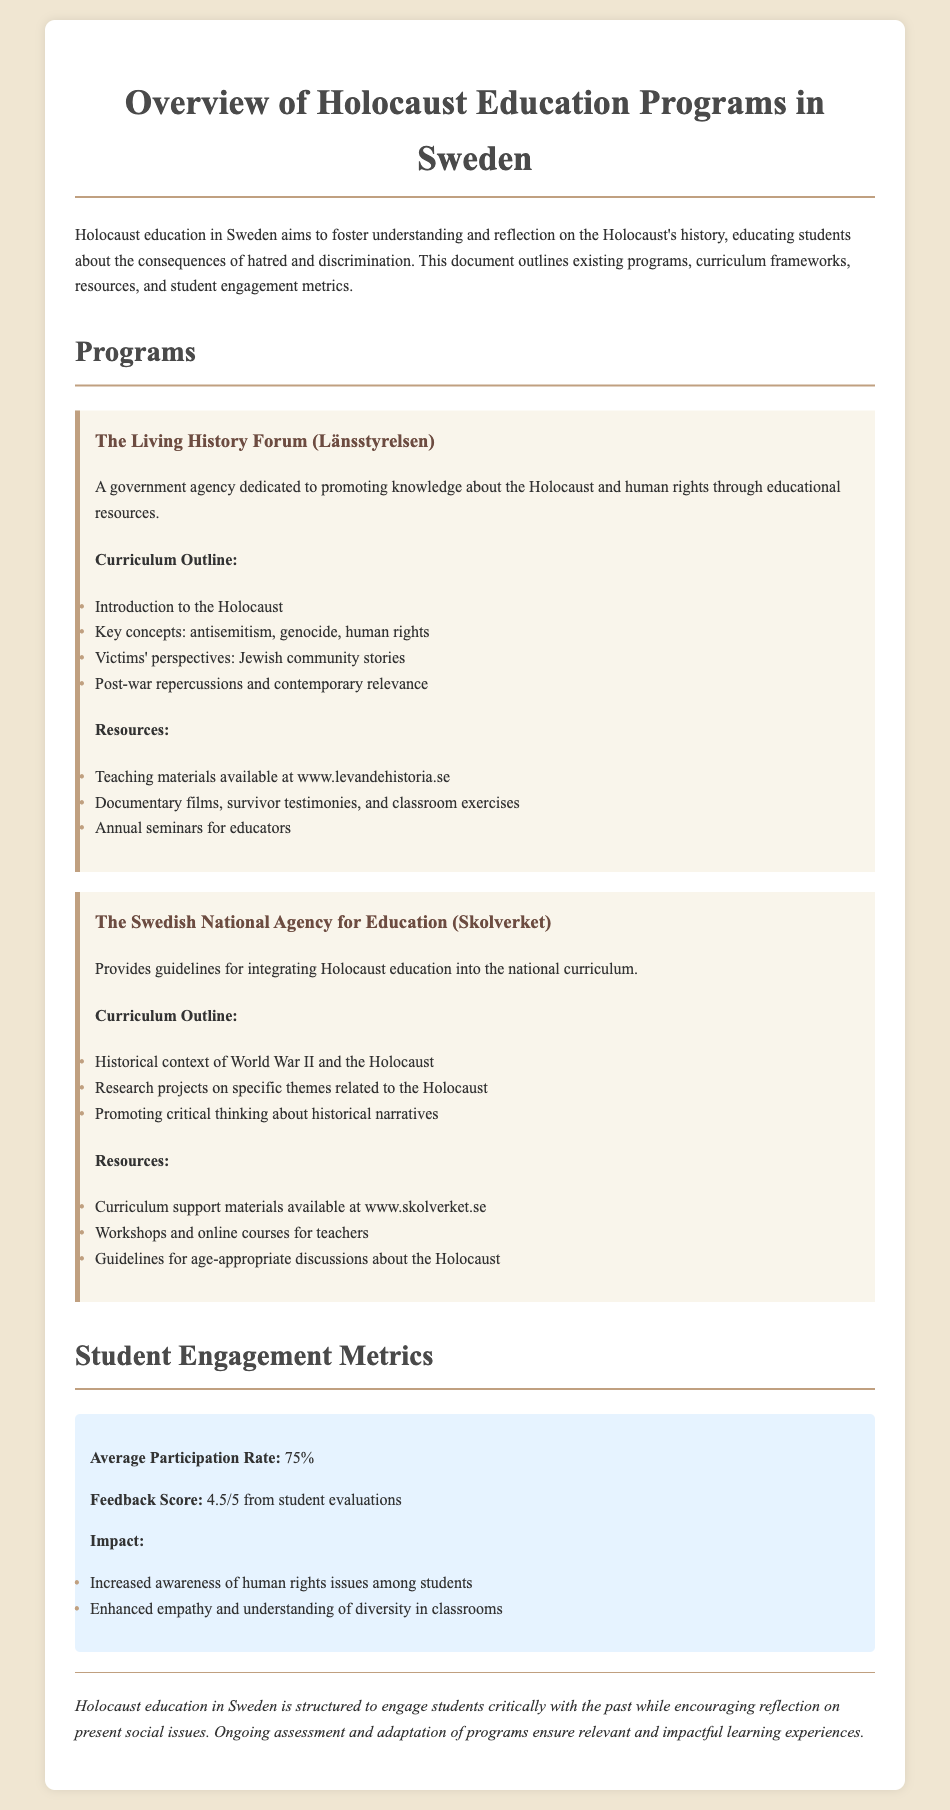What is the name of the government agency focused on Holocaust education? The document states that "The Living History Forum" is a government agency dedicated to promoting knowledge about the Holocaust.
Answer: The Living History Forum What is the curriculum outline's first topic under The Living History Forum? The document lists "Introduction to the Holocaust" as the first topic in the curriculum outline.
Answer: Introduction to the Holocaust What is the average participation rate for Holocaust education programs? The document indicates that the average participation rate is 75%.
Answer: 75% Which institution provides guidelines for integrating Holocaust education into the national curriculum? The document mentions "The Swedish National Agency for Education" as the provider of guidelines.
Answer: The Swedish National Agency for Education What is the feedback score from student evaluations? The document states that the feedback score is 4.5 out of 5 from evaluations.
Answer: 4.5/5 What type of resources does The Swedish National Agency for Education provide? The document states that it provides "curriculum support materials available at www.skolverket.se".
Answer: Curriculum support materials What is the main goal of Holocaust education in Sweden? The document describes the aim as fostering understanding and reflection on the Holocaust's history.
Answer: Understanding and reflection What percentage of students reported increased awareness of human rights issues? The document highlights an increase in awareness, though it does not provide a specific percentage; this represents an aspect of engagement metrics.
Answer: Increased awareness What is one of the thematic focuses for research projects in the curriculum? The document specifies that students engage in "research projects on specific themes related to the Holocaust".
Answer: Specific themes related to the Holocaust 